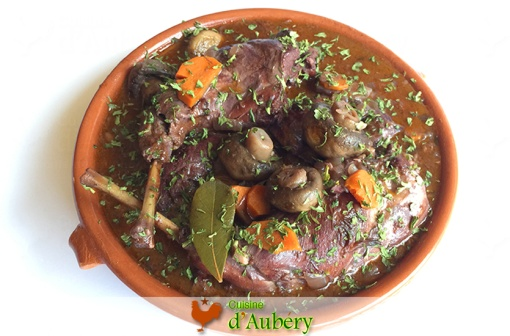If this dish were a character in a movie, what role would it play? If this **Coq au Vin** were a character in a movie, it would undoubtedly be the wise, comforting elder – the dependable figure who has seen it all and always has the perfect advice or warm hug to offer. This character would be essential during difficult moments, nurturing the protagonists with hearty wisdom and comforting presence, much like how the dish itself provides warmth and satisfaction. 